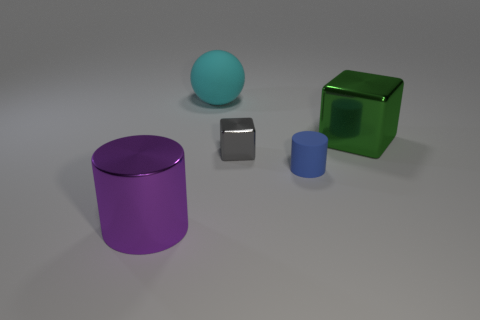Can you tell me what the objects in this image might be used for? Certainly! The purple cylinder looks like a container, potentially for holding small items or as a decorative piece. The small gray metal object might serve as a paperweight, and the green cube could either be a storage box or an artistic display. The blue sphere and the smaller blue cylinder may be decorative or used in various tabletop games or educational activities. 